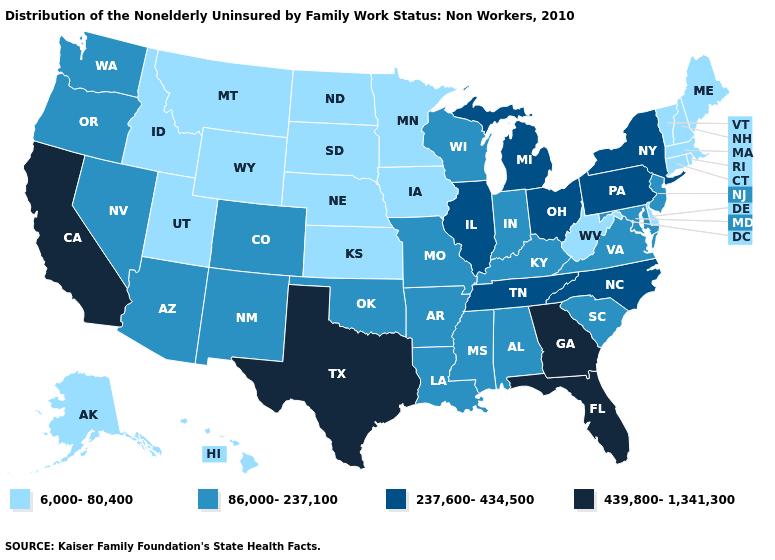Among the states that border South Carolina , which have the lowest value?
Short answer required. North Carolina. What is the lowest value in the South?
Short answer required. 6,000-80,400. Name the states that have a value in the range 86,000-237,100?
Answer briefly. Alabama, Arizona, Arkansas, Colorado, Indiana, Kentucky, Louisiana, Maryland, Mississippi, Missouri, Nevada, New Jersey, New Mexico, Oklahoma, Oregon, South Carolina, Virginia, Washington, Wisconsin. What is the value of Colorado?
Concise answer only. 86,000-237,100. What is the lowest value in states that border South Carolina?
Write a very short answer. 237,600-434,500. Which states hav the highest value in the MidWest?
Short answer required. Illinois, Michigan, Ohio. Does New Mexico have the highest value in the West?
Quick response, please. No. Is the legend a continuous bar?
Concise answer only. No. Does the map have missing data?
Keep it brief. No. Name the states that have a value in the range 237,600-434,500?
Be succinct. Illinois, Michigan, New York, North Carolina, Ohio, Pennsylvania, Tennessee. Is the legend a continuous bar?
Keep it brief. No. Does the first symbol in the legend represent the smallest category?
Give a very brief answer. Yes. Which states have the lowest value in the USA?
Concise answer only. Alaska, Connecticut, Delaware, Hawaii, Idaho, Iowa, Kansas, Maine, Massachusetts, Minnesota, Montana, Nebraska, New Hampshire, North Dakota, Rhode Island, South Dakota, Utah, Vermont, West Virginia, Wyoming. Name the states that have a value in the range 439,800-1,341,300?
Answer briefly. California, Florida, Georgia, Texas. Which states have the highest value in the USA?
Write a very short answer. California, Florida, Georgia, Texas. 